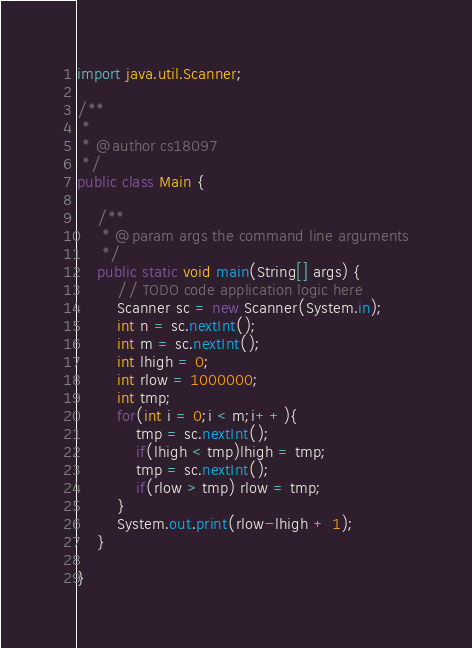<code> <loc_0><loc_0><loc_500><loc_500><_Java_>
import java.util.Scanner;

/**
 *
 * @author cs18097
 */
public class Main {

    /**
     * @param args the command line arguments
     */
    public static void main(String[] args) {
        // TODO code application logic here
        Scanner sc = new Scanner(System.in);
        int n = sc.nextInt();
        int m = sc.nextInt();
        int lhigh = 0;
        int rlow = 1000000;
        int tmp;
        for(int i = 0;i < m;i++){
            tmp = sc.nextInt();
            if(lhigh < tmp)lhigh = tmp;
            tmp = sc.nextInt();
            if(rlow > tmp) rlow = tmp;
        }
        System.out.print(rlow-lhigh + 1);
    }
    
}
</code> 